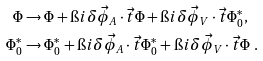<formula> <loc_0><loc_0><loc_500><loc_500>\Phi & \rightarrow \Phi + \i i \delta \vec { \phi } _ { A } \cdot \vec { t } \Phi + \i i \delta \vec { \phi } _ { V } \cdot \vec { t } \Phi _ { 0 } ^ { * } , \\ \Phi _ { 0 } ^ { * } & \rightarrow \Phi _ { 0 } ^ { * } + \i i \delta \vec { \phi } _ { A } \cdot \vec { t } \Phi _ { 0 } ^ { * } + \i i \delta \vec { \phi } _ { V } \cdot \vec { t } \Phi \ .</formula> 